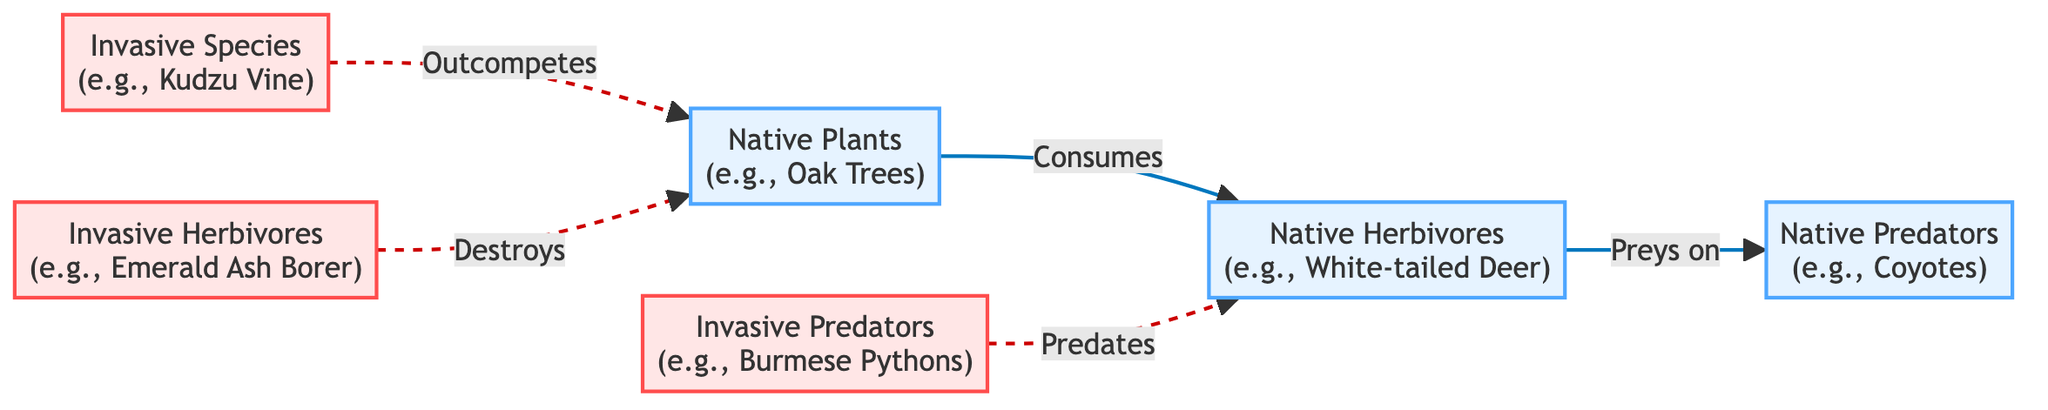What is the total number of nodes in the food chain diagram? The diagram contains three native nodes (Native Plants, Native Herbivores, Native Predators) and three invasive nodes (Invasive Species, Invasive Herbivores, Invasive Predators), for a total of six nodes.
Answer: 6 Which species competes with native plants? The diagram indicates that Kudzu Vine (Invasive Species) outcompetes native plants. This relationship is shown by the dashed arrow connecting them, which signifies competition.
Answer: Kudzu Vine How many edges are there in the diagram? The diagram has three solid edges representing consumption relationships and two dashed edges representing competitive relationships, resulting in a total of five edges.
Answer: 5 What role does the Emerald Ash Borer have in the food chain? The Emerald Ash Borer is classified as an invasive herbivore that destroys native plants, as indicated by the dashed arrow pointing from it to native plants, illustrating this destructive relationship.
Answer: Destroys Which organism is the top predator among the native species? The diagram shows Coyotes as the native predators that prey on native herbivores, making them the top predator in the native category.
Answer: Coyotes What type of disruption does the Burmese Python cause? In the diagram, the Burmese Python is an invasive predator that preys on native herbivores (e.g., White-tailed Deer). This relationship signifies a disruption to the food chain because it increases the predation pressure on native herbivores.
Answer: Predates What is the relationship type between native herbivores and native predators? The relationship between native herbivores and native predators is described as 'preys on', which signifies a direct predator-prey interaction indicated by the solid arrow connecting the two.
Answer: Preys on Which group of species is represented with a dashed line? The invasive species are represented with dashed lines indicating competitive relationships with the native species, specifically Kudzu Vine competing with native plants and the Emerald Ash Borer impacting them.
Answer: Invasive Species 